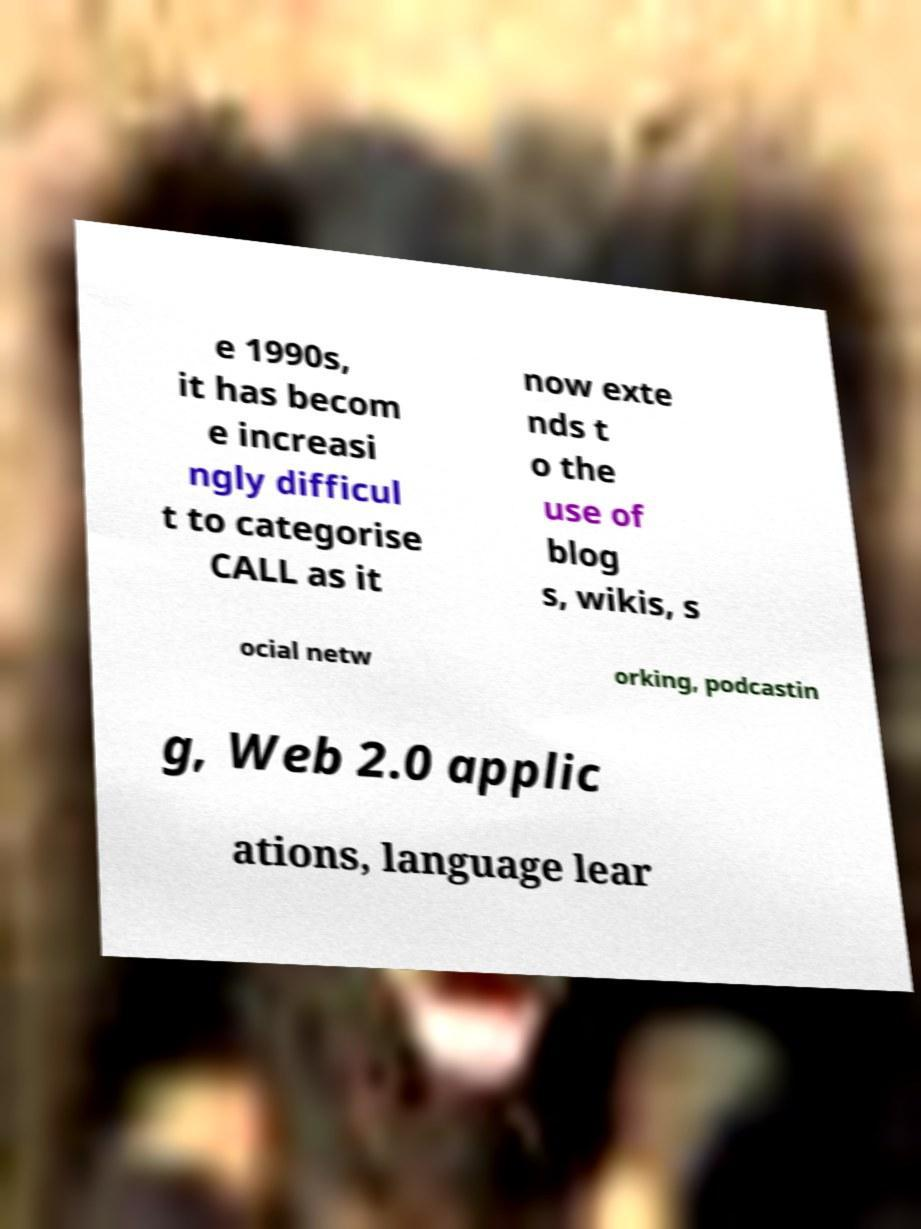Could you assist in decoding the text presented in this image and type it out clearly? e 1990s, it has becom e increasi ngly difficul t to categorise CALL as it now exte nds t o the use of blog s, wikis, s ocial netw orking, podcastin g, Web 2.0 applic ations, language lear 